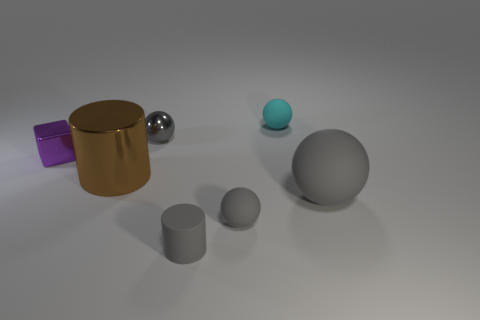The thing that is on the left side of the large object that is on the left side of the tiny gray sphere that is behind the purple object is what color?
Keep it short and to the point. Purple. Is the color of the small cylinder the same as the small metal sphere?
Keep it short and to the point. Yes. How many other things are the same size as the brown thing?
Provide a short and direct response. 1. Is the number of big gray objects that are behind the cyan matte ball greater than the number of cyan rubber things that are on the left side of the purple metal thing?
Your answer should be compact. No. What is the color of the matte object that is to the right of the matte thing that is behind the tiny purple metallic object?
Offer a terse response. Gray. Is the material of the tiny purple cube the same as the small gray cylinder?
Offer a very short reply. No. Is there another purple metal thing that has the same shape as the purple metallic object?
Offer a very short reply. No. Do the tiny matte sphere behind the purple object and the tiny rubber cylinder have the same color?
Keep it short and to the point. No. There is a cyan sphere to the right of the small cube; is it the same size as the gray thing behind the purple thing?
Make the answer very short. Yes. There is a sphere that is the same material as the purple block; what size is it?
Make the answer very short. Small. 